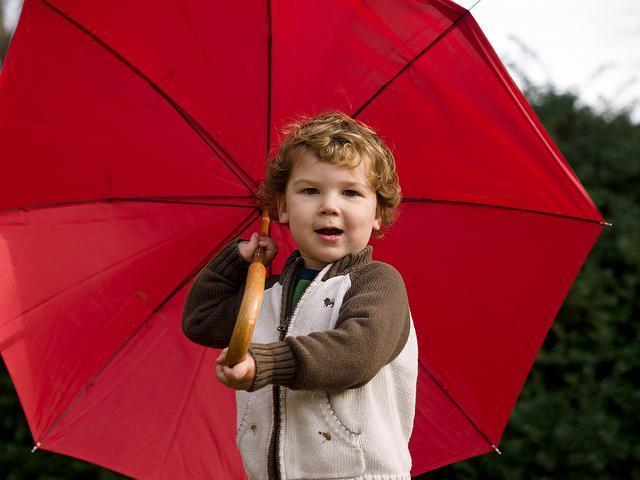How many zebras are there?
Give a very brief answer. 0. 